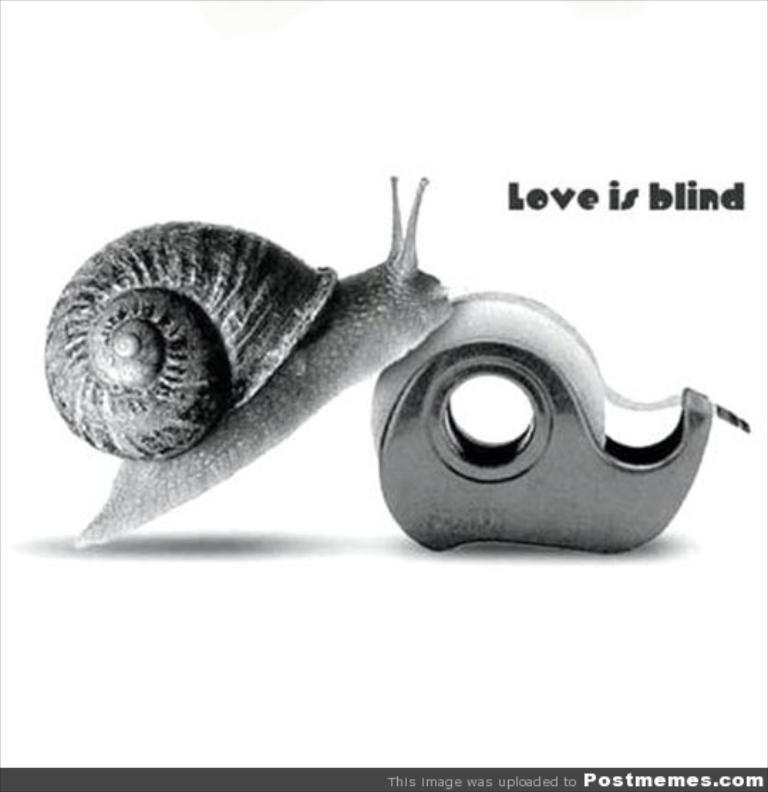What type of animal is in the image? There is a snail in the image. What is the snail resting on or attached to? The snail is on an object. What is the color scheme of the image? The image is black and white. Are there any words or letters visible in the image? Yes, there is text visible in the image. How does the snail use the fan in the image? There is no fan present in the image; it only features a snail on an object and text. 